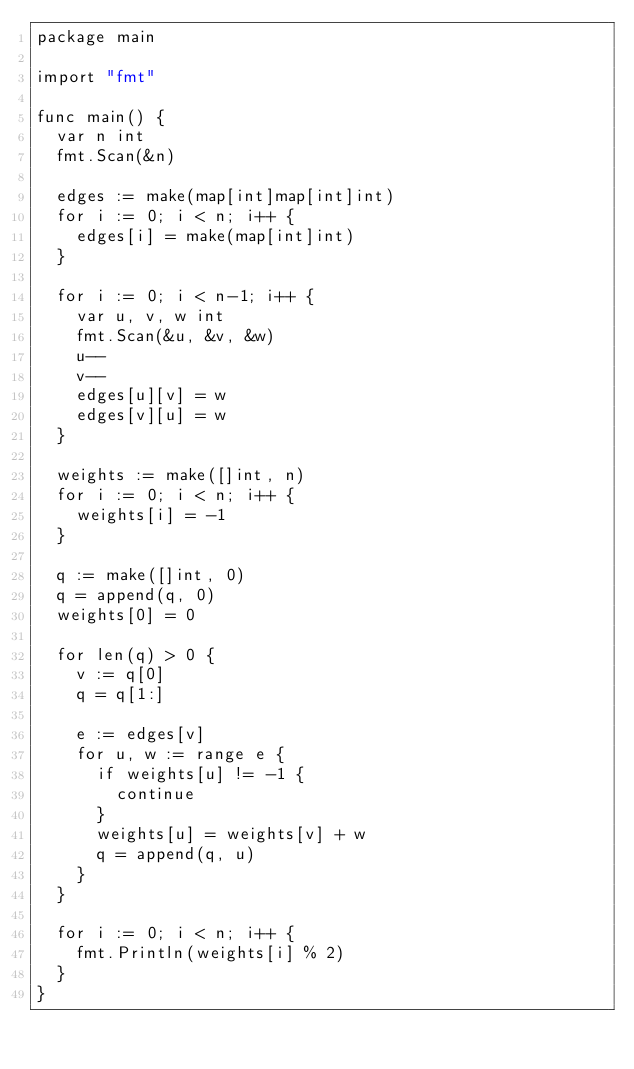Convert code to text. <code><loc_0><loc_0><loc_500><loc_500><_Go_>package main

import "fmt"

func main() {
	var n int
	fmt.Scan(&n)

	edges := make(map[int]map[int]int)
	for i := 0; i < n; i++ {
		edges[i] = make(map[int]int)
	}

	for i := 0; i < n-1; i++ {
		var u, v, w int
		fmt.Scan(&u, &v, &w)
		u--
		v--
		edges[u][v] = w
		edges[v][u] = w
	}

	weights := make([]int, n)
	for i := 0; i < n; i++ {
		weights[i] = -1
	}

	q := make([]int, 0)
	q = append(q, 0)
	weights[0] = 0

	for len(q) > 0 {
		v := q[0]
		q = q[1:]

		e := edges[v]
		for u, w := range e {
			if weights[u] != -1 {
				continue
			}
			weights[u] = weights[v] + w
			q = append(q, u)
		}
	}

	for i := 0; i < n; i++ {
		fmt.Println(weights[i] % 2)
	}
}
</code> 